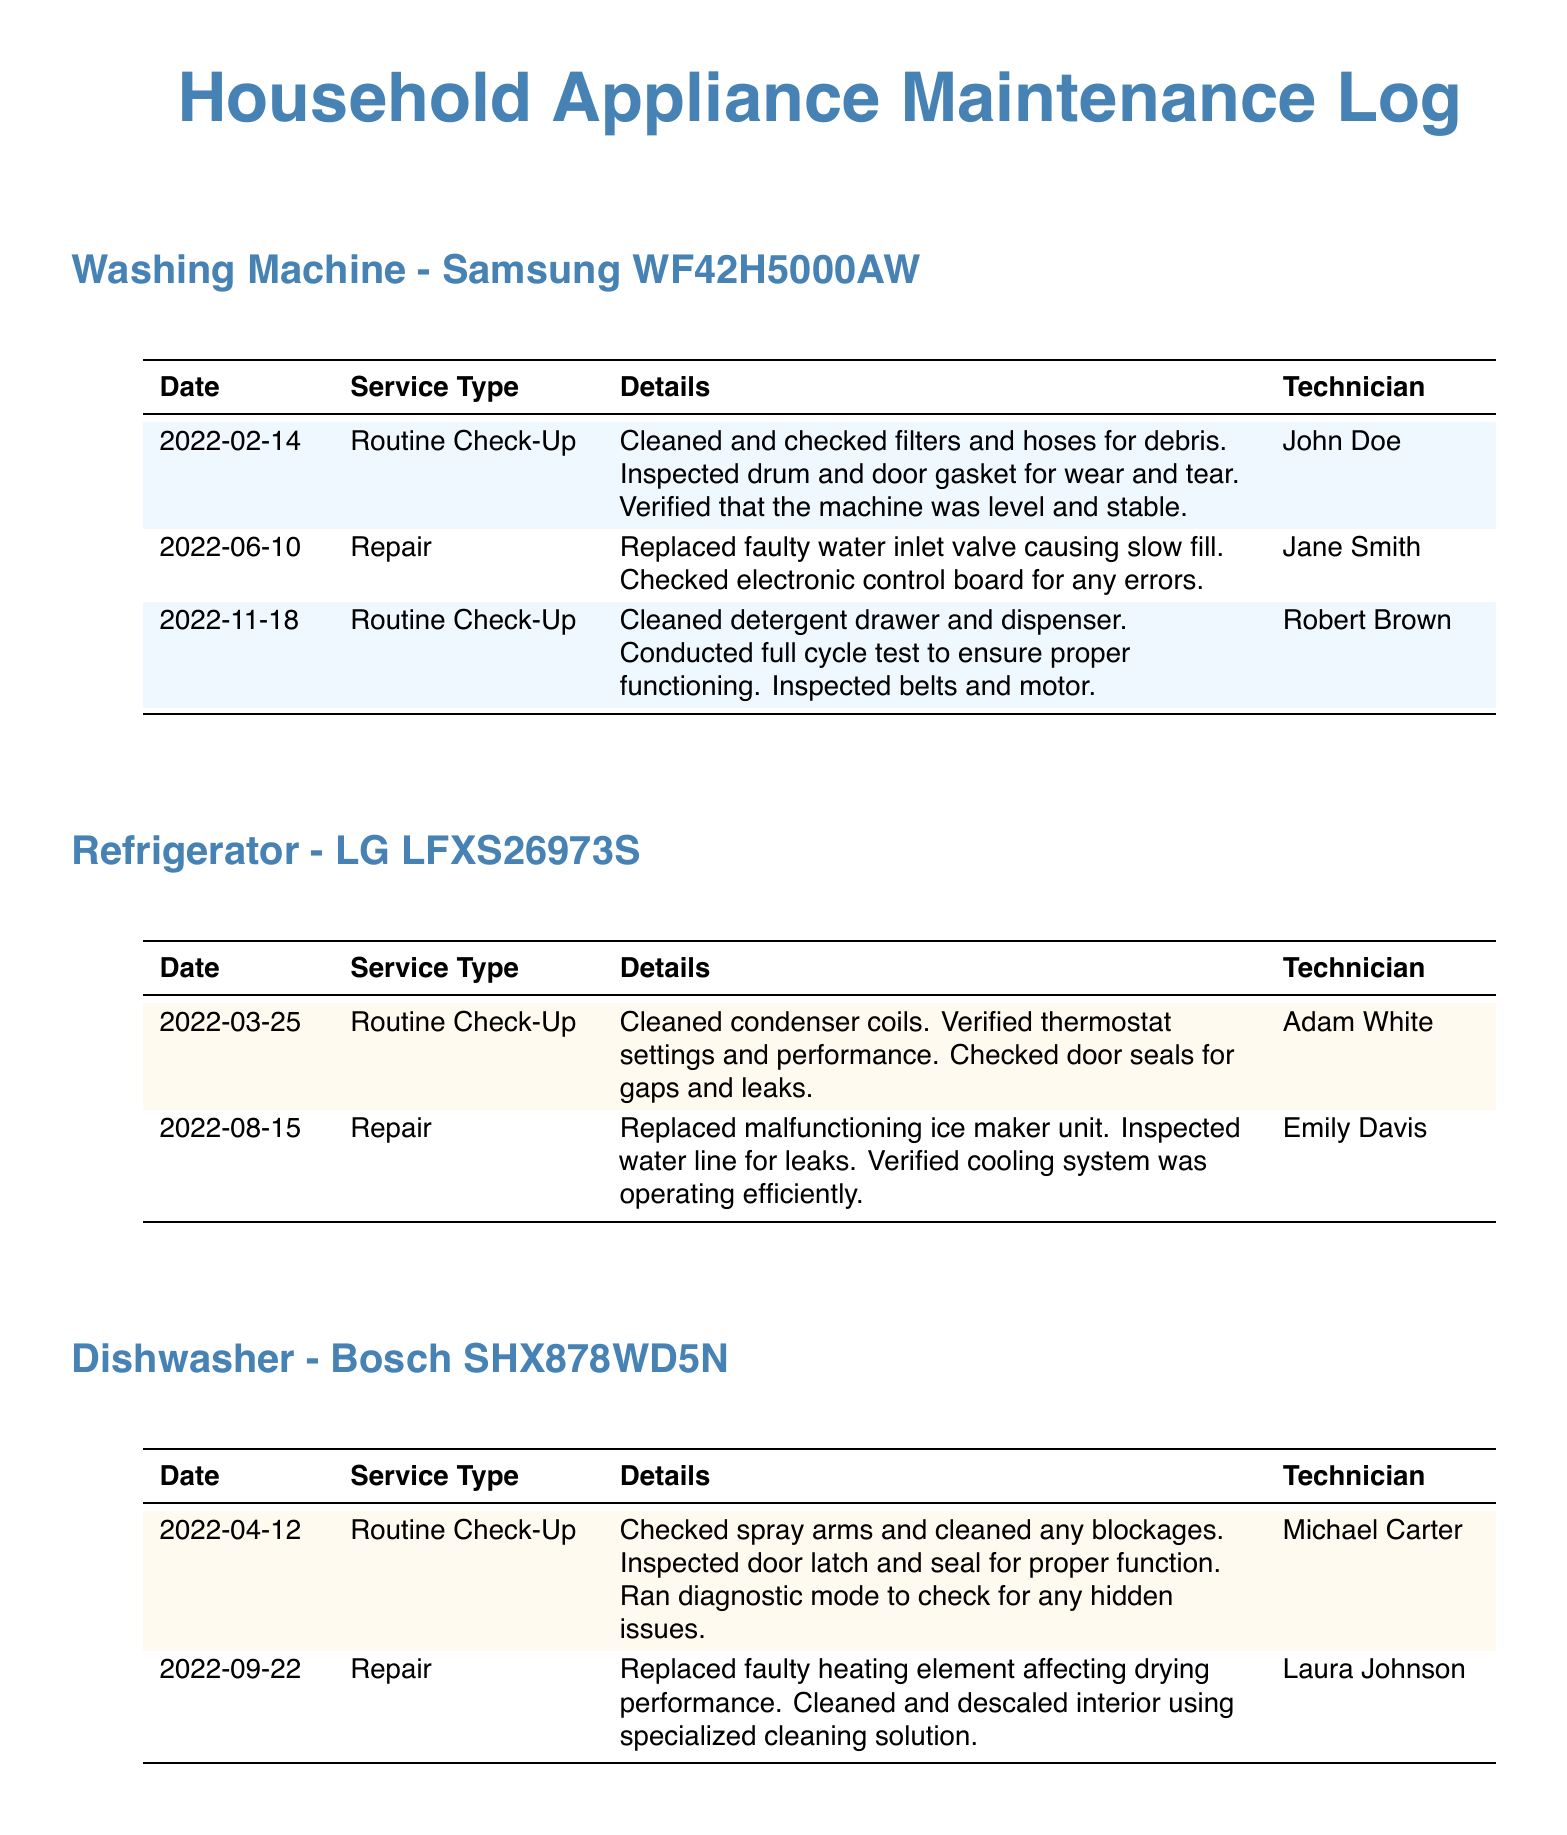What is the brand of the washing machine? The brand of the washing machine is specified in the log under the device section.
Answer: Samsung When was the refrigerator last serviced? The last service date of the refrigerator is taken from the log for that appliance.
Answer: August 15, 2022 Who conducted the routine check-up for the dishwasher? The technician who performed the routine check-up is listed in the service details in the document.
Answer: Michael Carter How many routine check-ups were performed on the washing machine in 2022? The total number of routine check-ups can be counted from the washing machine service records.
Answer: 2 What was replaced on the refrigerator during the repair in August? The specific component replaced during the repair is mentioned in the details for that service.
Answer: Ice maker unit What was the reason for the washing machine repair on June 10? The detailed reason for the repair is documented in the service notes for the washing machine.
Answer: Faulty water inlet valve Which appliance had a fault related to a heating element? The specific appliance associated with the heating element issue can be identified from the repair details.
Answer: Dishwasher How many different technicians serviced the refrigerator in 2022? The count of distinct technicians listed for refrigerator services in the document gives this answer.
Answer: 2 